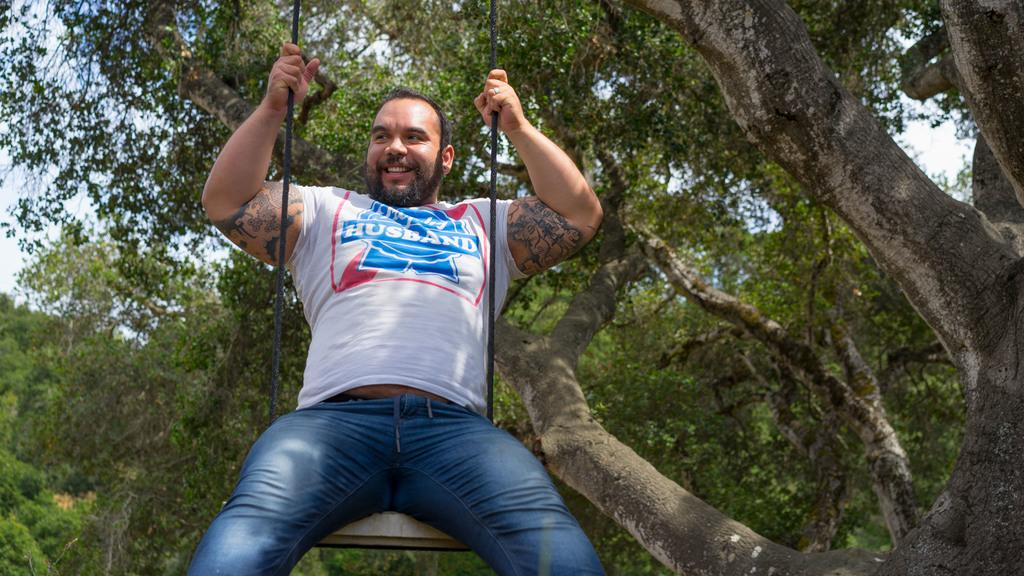Who or what is the main subject in the image? There is a person in the image. What is the person doing in the image? The person is sitting on a swing. What can be seen in the background of the image? There are trees visible in the background of the image. What type of mitten is the person wearing in the image? There is no mitten visible in the image; the person is sitting on a swing with no mention of gloves or mittens. 